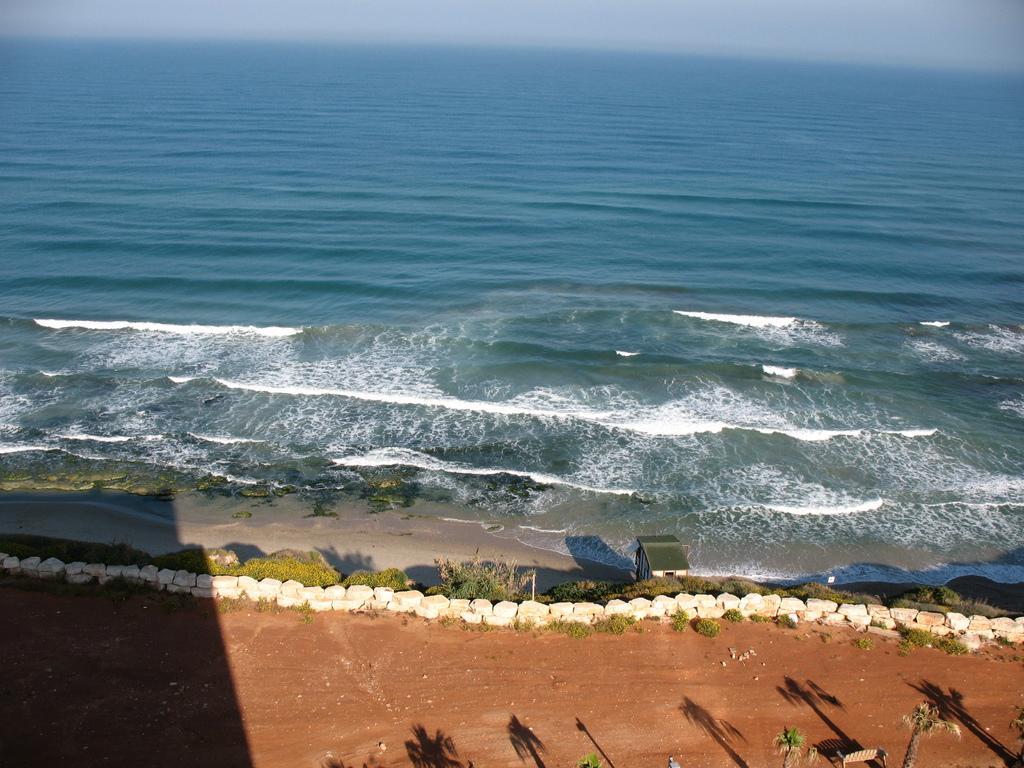How would you summarize this image in a sentence or two? In this picture we can see trees,stone wall,water and we can see sky in the background. 